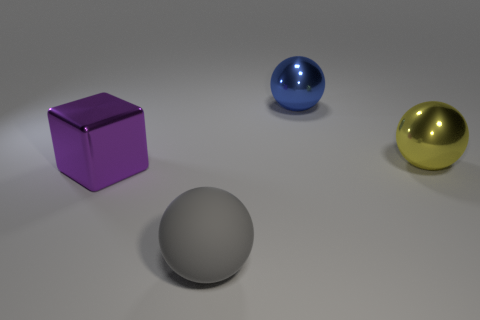What number of objects are either large shiny balls or purple blocks that are on the left side of the large yellow metallic sphere?
Your answer should be very brief. 3. What size is the blue ball that is made of the same material as the yellow sphere?
Give a very brief answer. Large. What shape is the large metal object that is to the left of the sphere in front of the large purple block?
Provide a succinct answer. Cube. There is a object that is to the left of the blue sphere and behind the gray ball; what is its size?
Make the answer very short. Large. Are there any tiny cyan rubber objects of the same shape as the big rubber object?
Your answer should be very brief. No. Are there any other things that have the same shape as the large purple shiny thing?
Provide a short and direct response. No. The sphere that is to the left of the big thing that is behind the sphere that is right of the large blue thing is made of what material?
Keep it short and to the point. Rubber. Is there a yellow metal sphere that has the same size as the blue sphere?
Your answer should be very brief. Yes. There is a big object that is in front of the shiny thing on the left side of the large matte ball; what color is it?
Provide a short and direct response. Gray. How many large metallic objects are there?
Make the answer very short. 3. 